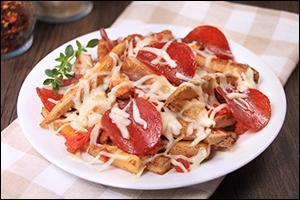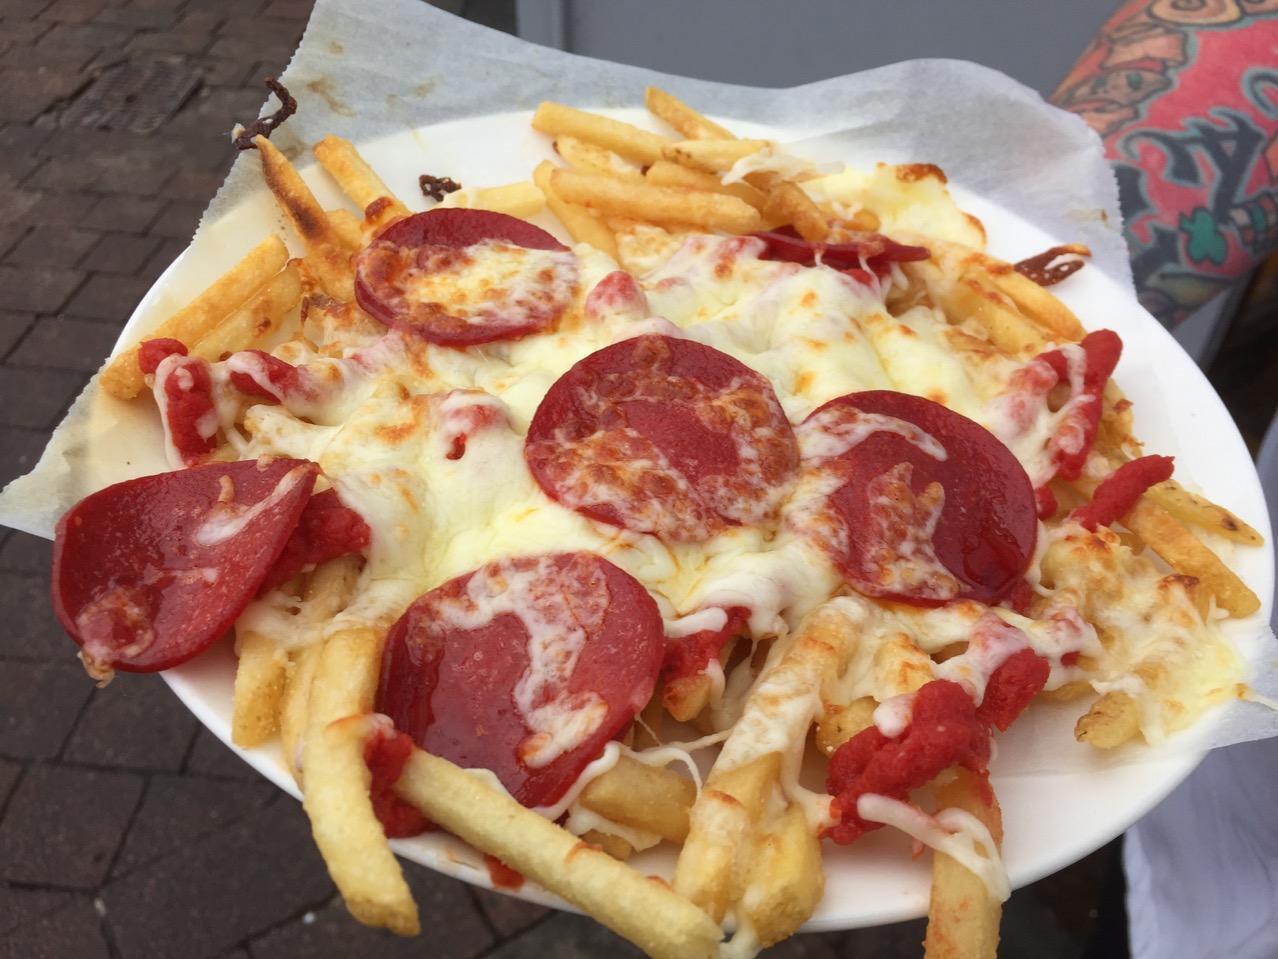The first image is the image on the left, the second image is the image on the right. Examine the images to the left and right. Is the description "In at least one image there is a white plate with pizza fries and a burger next to ketchup." accurate? Answer yes or no. No. The first image is the image on the left, the second image is the image on the right. Assess this claim about the two images: "At least one burger is shown on a plate with some pizza fries.". Correct or not? Answer yes or no. No. 